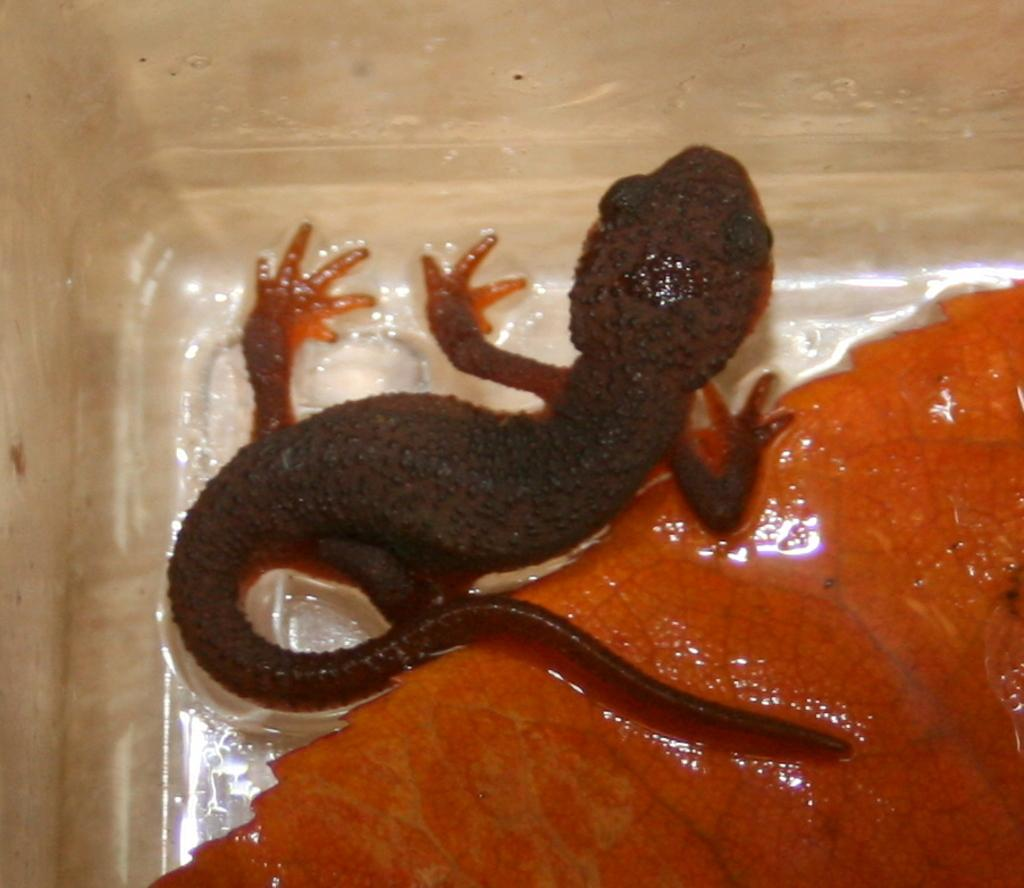What type of animal is present in the image? There is a lizard in the image. What is the color of the lizard? The lizard is black in color. What other object can be seen in the image? There is an orange color leaf in the image. What is the color of the background in the image? The background of the image is cream in color. Where is the crowd located in the image? There is no crowd present in the image. What type of fruit is being held by the lizard in the image? There is no fruit, including a pear, present in the image. 